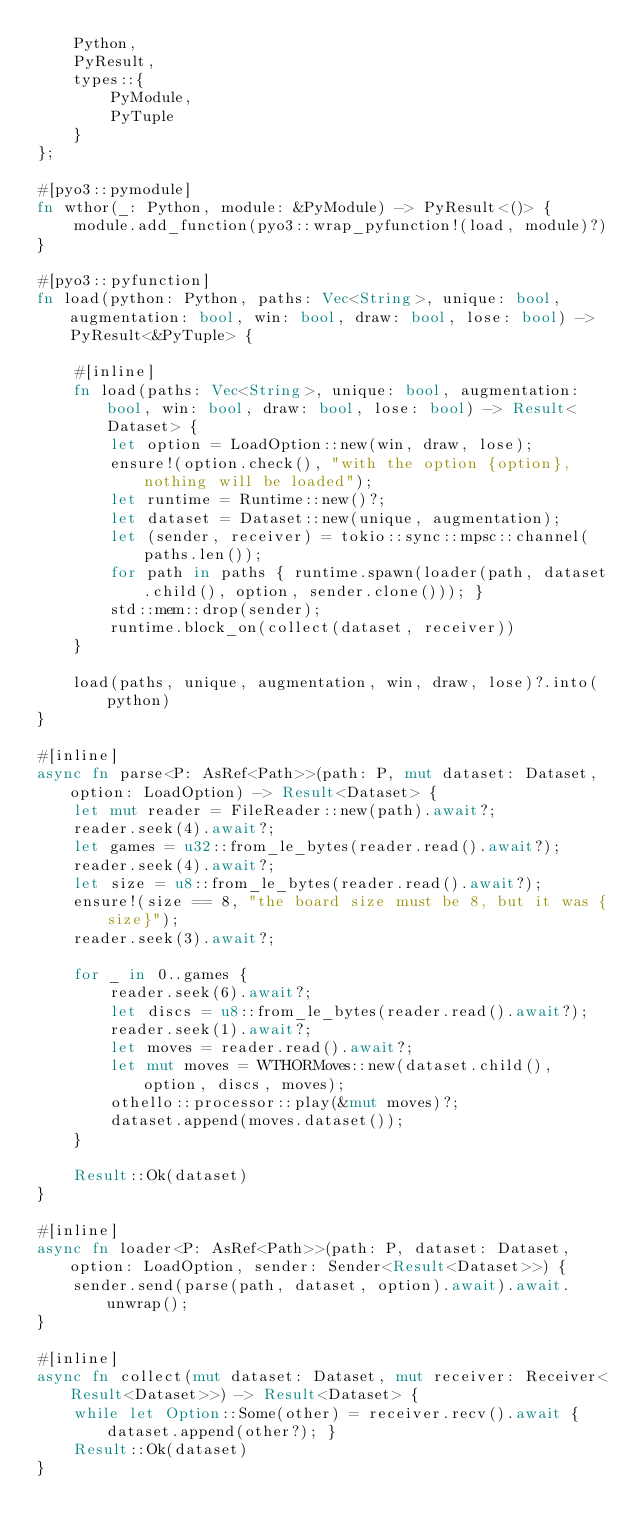<code> <loc_0><loc_0><loc_500><loc_500><_Rust_>    Python,
    PyResult,
    types::{
        PyModule,
        PyTuple
    }
};

#[pyo3::pymodule]
fn wthor(_: Python, module: &PyModule) -> PyResult<()> {
    module.add_function(pyo3::wrap_pyfunction!(load, module)?)
}

#[pyo3::pyfunction]
fn load(python: Python, paths: Vec<String>, unique: bool, augmentation: bool, win: bool, draw: bool, lose: bool) -> PyResult<&PyTuple> {

    #[inline]
    fn load(paths: Vec<String>, unique: bool, augmentation: bool, win: bool, draw: bool, lose: bool) -> Result<Dataset> {
        let option = LoadOption::new(win, draw, lose);
        ensure!(option.check(), "with the option {option}, nothing will be loaded");
        let runtime = Runtime::new()?;
        let dataset = Dataset::new(unique, augmentation);
        let (sender, receiver) = tokio::sync::mpsc::channel(paths.len());
        for path in paths { runtime.spawn(loader(path, dataset.child(), option, sender.clone())); }
        std::mem::drop(sender);
        runtime.block_on(collect(dataset, receiver))
    }

    load(paths, unique, augmentation, win, draw, lose)?.into(python)
}

#[inline]
async fn parse<P: AsRef<Path>>(path: P, mut dataset: Dataset, option: LoadOption) -> Result<Dataset> {
    let mut reader = FileReader::new(path).await?;
    reader.seek(4).await?;
    let games = u32::from_le_bytes(reader.read().await?);
    reader.seek(4).await?;
    let size = u8::from_le_bytes(reader.read().await?);
    ensure!(size == 8, "the board size must be 8, but it was {size}");
    reader.seek(3).await?;

    for _ in 0..games {
        reader.seek(6).await?;
        let discs = u8::from_le_bytes(reader.read().await?);
        reader.seek(1).await?;
        let moves = reader.read().await?;
        let mut moves = WTHORMoves::new(dataset.child(), option, discs, moves);
        othello::processor::play(&mut moves)?;
        dataset.append(moves.dataset());
    }

    Result::Ok(dataset)
}

#[inline]
async fn loader<P: AsRef<Path>>(path: P, dataset: Dataset, option: LoadOption, sender: Sender<Result<Dataset>>) {
    sender.send(parse(path, dataset, option).await).await.unwrap();
}

#[inline]
async fn collect(mut dataset: Dataset, mut receiver: Receiver<Result<Dataset>>) -> Result<Dataset> {
    while let Option::Some(other) = receiver.recv().await { dataset.append(other?); }
    Result::Ok(dataset)
}
</code> 